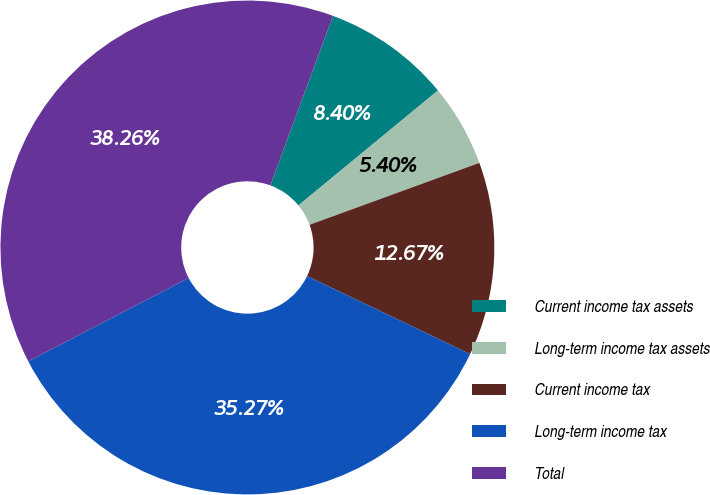Convert chart to OTSL. <chart><loc_0><loc_0><loc_500><loc_500><pie_chart><fcel>Current income tax assets<fcel>Long-term income tax assets<fcel>Current income tax<fcel>Long-term income tax<fcel>Total<nl><fcel>8.4%<fcel>5.4%<fcel>12.67%<fcel>35.27%<fcel>38.26%<nl></chart> 